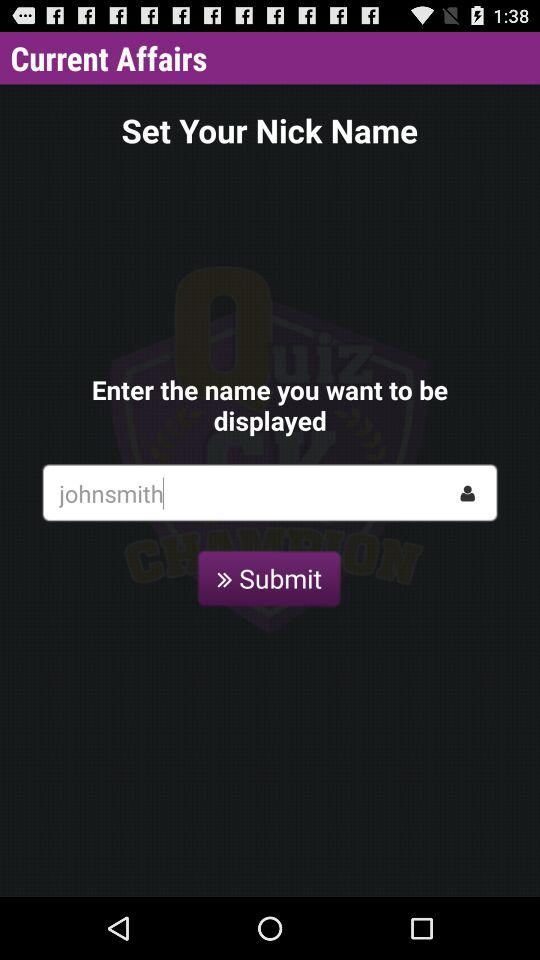What is the entered name? The entered name is "johnsmith". 